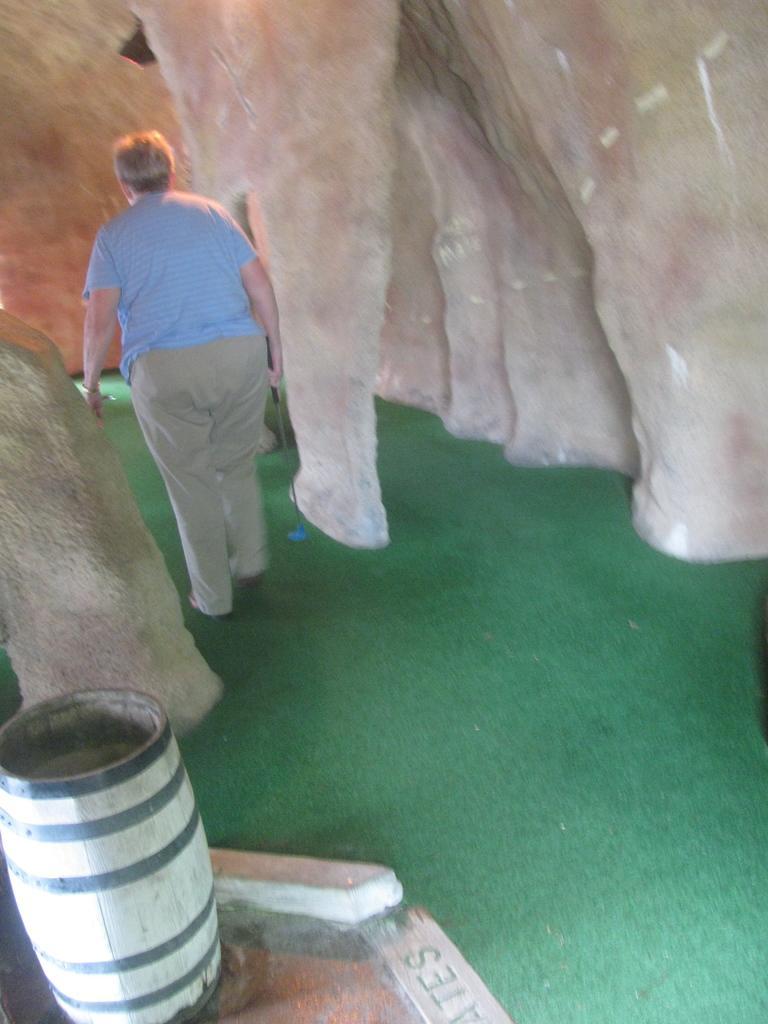How would you summarize this image in a sentence or two? In this image there is a man walking on a green mat, in the background there are pillars, in the bottom left there are drum. 